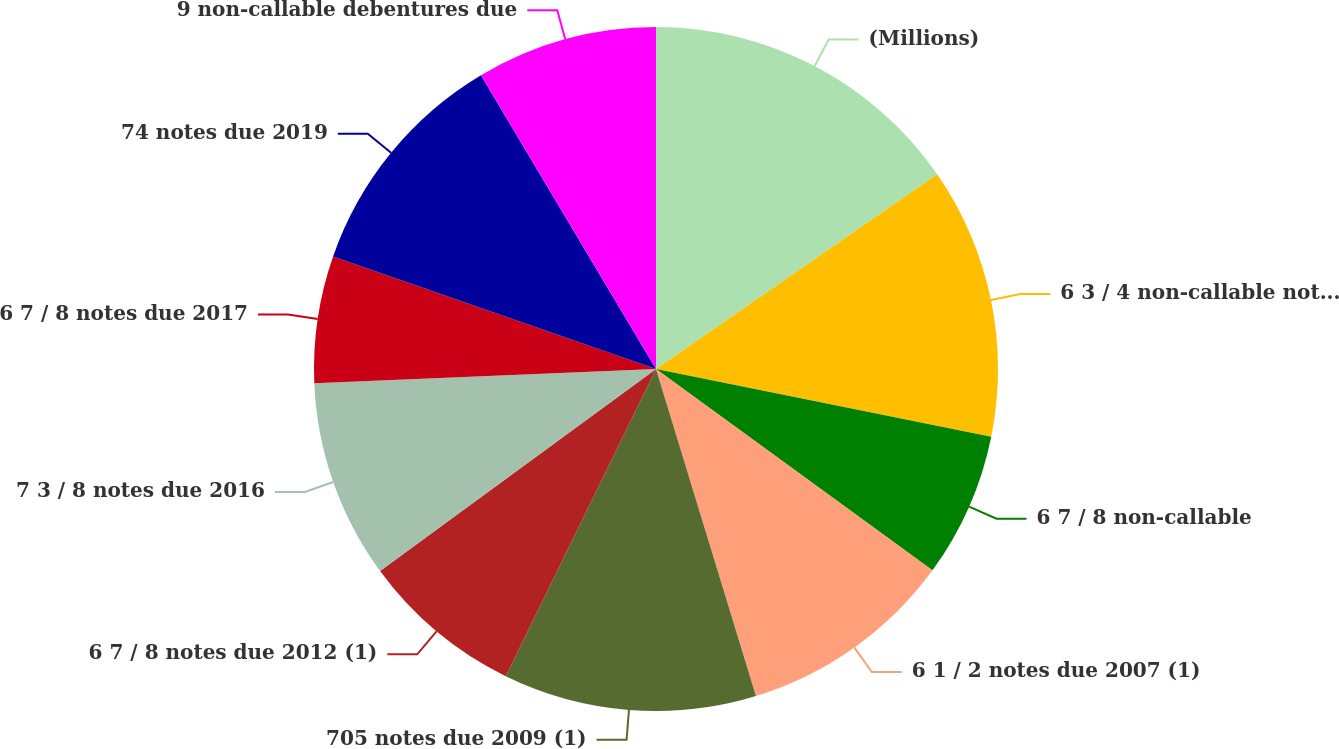Convert chart to OTSL. <chart><loc_0><loc_0><loc_500><loc_500><pie_chart><fcel>(Millions)<fcel>6 3 / 4 non-callable notes due<fcel>6 7 / 8 non-callable<fcel>6 1 / 2 notes due 2007 (1)<fcel>705 notes due 2009 (1)<fcel>6 7 / 8 notes due 2012 (1)<fcel>7 3 / 8 notes due 2016<fcel>6 7 / 8 notes due 2017<fcel>74 notes due 2019<fcel>9 non-callable debentures due<nl><fcel>15.36%<fcel>12.81%<fcel>6.85%<fcel>10.26%<fcel>11.96%<fcel>7.7%<fcel>9.4%<fcel>6.0%<fcel>11.11%<fcel>8.55%<nl></chart> 